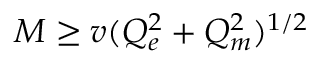Convert formula to latex. <formula><loc_0><loc_0><loc_500><loc_500>M \geq v ( Q _ { e } ^ { 2 } + Q _ { m } ^ { 2 } ) ^ { 1 / 2 }</formula> 